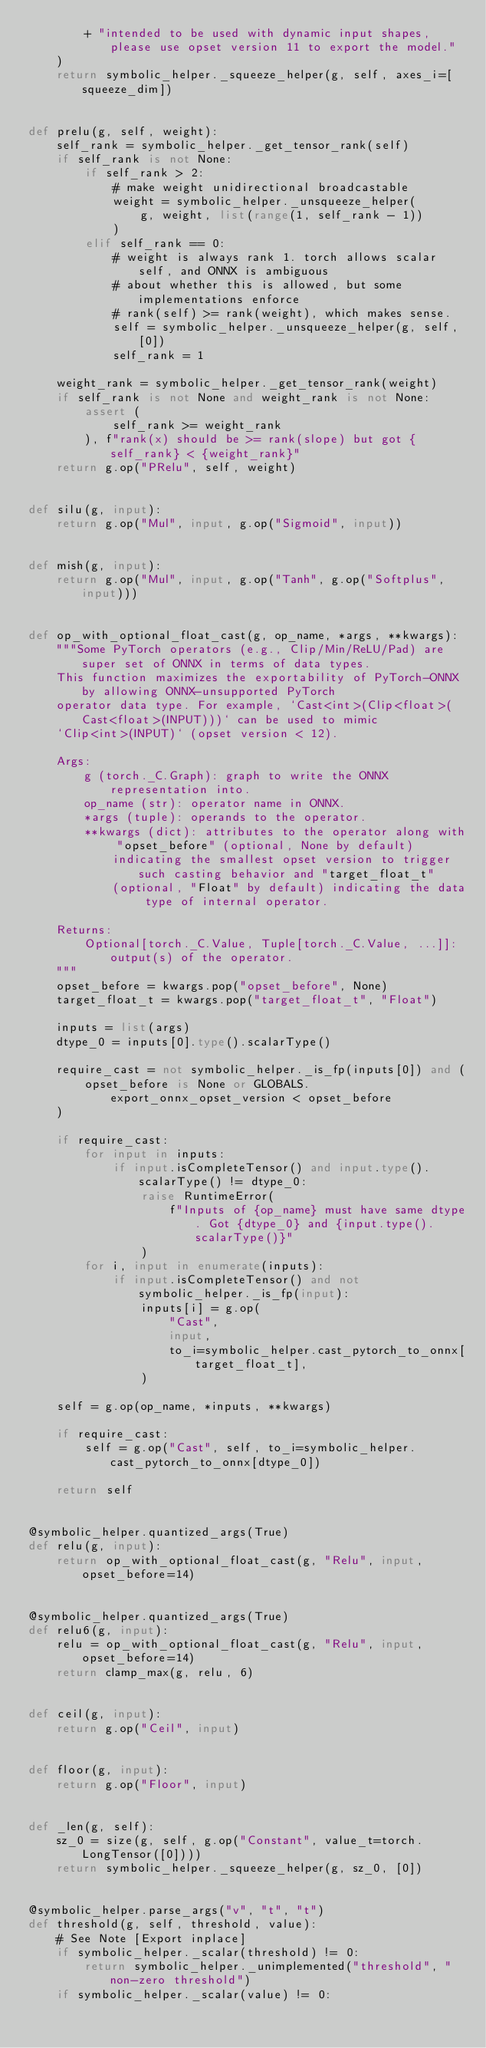Convert code to text. <code><loc_0><loc_0><loc_500><loc_500><_Python_>        + "intended to be used with dynamic input shapes, please use opset version 11 to export the model."
    )
    return symbolic_helper._squeeze_helper(g, self, axes_i=[squeeze_dim])


def prelu(g, self, weight):
    self_rank = symbolic_helper._get_tensor_rank(self)
    if self_rank is not None:
        if self_rank > 2:
            # make weight unidirectional broadcastable
            weight = symbolic_helper._unsqueeze_helper(
                g, weight, list(range(1, self_rank - 1))
            )
        elif self_rank == 0:
            # weight is always rank 1. torch allows scalar self, and ONNX is ambiguous
            # about whether this is allowed, but some implementations enforce
            # rank(self) >= rank(weight), which makes sense.
            self = symbolic_helper._unsqueeze_helper(g, self, [0])
            self_rank = 1

    weight_rank = symbolic_helper._get_tensor_rank(weight)
    if self_rank is not None and weight_rank is not None:
        assert (
            self_rank >= weight_rank
        ), f"rank(x) should be >= rank(slope) but got {self_rank} < {weight_rank}"
    return g.op("PRelu", self, weight)


def silu(g, input):
    return g.op("Mul", input, g.op("Sigmoid", input))


def mish(g, input):
    return g.op("Mul", input, g.op("Tanh", g.op("Softplus", input)))


def op_with_optional_float_cast(g, op_name, *args, **kwargs):
    """Some PyTorch operators (e.g., Clip/Min/ReLU/Pad) are super set of ONNX in terms of data types.
    This function maximizes the exportability of PyTorch-ONNX by allowing ONNX-unsupported PyTorch
    operator data type. For example, `Cast<int>(Clip<float>(Cast<float>(INPUT)))` can be used to mimic
    `Clip<int>(INPUT)` (opset version < 12).

    Args:
        g (torch._C.Graph): graph to write the ONNX representation into.
        op_name (str): operator name in ONNX.
        *args (tuple): operands to the operator.
        **kwargs (dict): attributes to the operator along with "opset_before" (optional, None by default)
            indicating the smallest opset version to trigger such casting behavior and "target_float_t"
            (optional, "Float" by default) indicating the data type of internal operator.

    Returns:
        Optional[torch._C.Value, Tuple[torch._C.Value, ...]]: output(s) of the operator.
    """
    opset_before = kwargs.pop("opset_before", None)
    target_float_t = kwargs.pop("target_float_t", "Float")

    inputs = list(args)
    dtype_0 = inputs[0].type().scalarType()

    require_cast = not symbolic_helper._is_fp(inputs[0]) and (
        opset_before is None or GLOBALS.export_onnx_opset_version < opset_before
    )

    if require_cast:
        for input in inputs:
            if input.isCompleteTensor() and input.type().scalarType() != dtype_0:
                raise RuntimeError(
                    f"Inputs of {op_name} must have same dtype. Got {dtype_0} and {input.type().scalarType()}"
                )
        for i, input in enumerate(inputs):
            if input.isCompleteTensor() and not symbolic_helper._is_fp(input):
                inputs[i] = g.op(
                    "Cast",
                    input,
                    to_i=symbolic_helper.cast_pytorch_to_onnx[target_float_t],
                )

    self = g.op(op_name, *inputs, **kwargs)

    if require_cast:
        self = g.op("Cast", self, to_i=symbolic_helper.cast_pytorch_to_onnx[dtype_0])

    return self


@symbolic_helper.quantized_args(True)
def relu(g, input):
    return op_with_optional_float_cast(g, "Relu", input, opset_before=14)


@symbolic_helper.quantized_args(True)
def relu6(g, input):
    relu = op_with_optional_float_cast(g, "Relu", input, opset_before=14)
    return clamp_max(g, relu, 6)


def ceil(g, input):
    return g.op("Ceil", input)


def floor(g, input):
    return g.op("Floor", input)


def _len(g, self):
    sz_0 = size(g, self, g.op("Constant", value_t=torch.LongTensor([0])))
    return symbolic_helper._squeeze_helper(g, sz_0, [0])


@symbolic_helper.parse_args("v", "t", "t")
def threshold(g, self, threshold, value):
    # See Note [Export inplace]
    if symbolic_helper._scalar(threshold) != 0:
        return symbolic_helper._unimplemented("threshold", "non-zero threshold")
    if symbolic_helper._scalar(value) != 0:</code> 